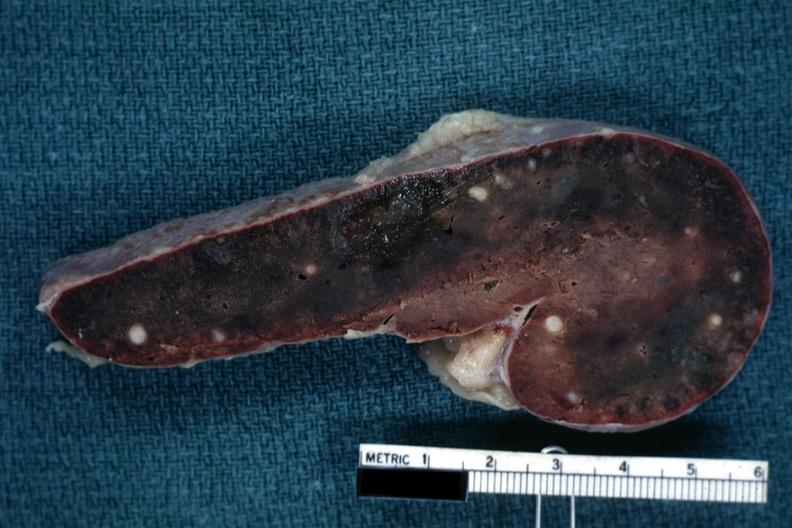s spleen present?
Answer the question using a single word or phrase. Yes 